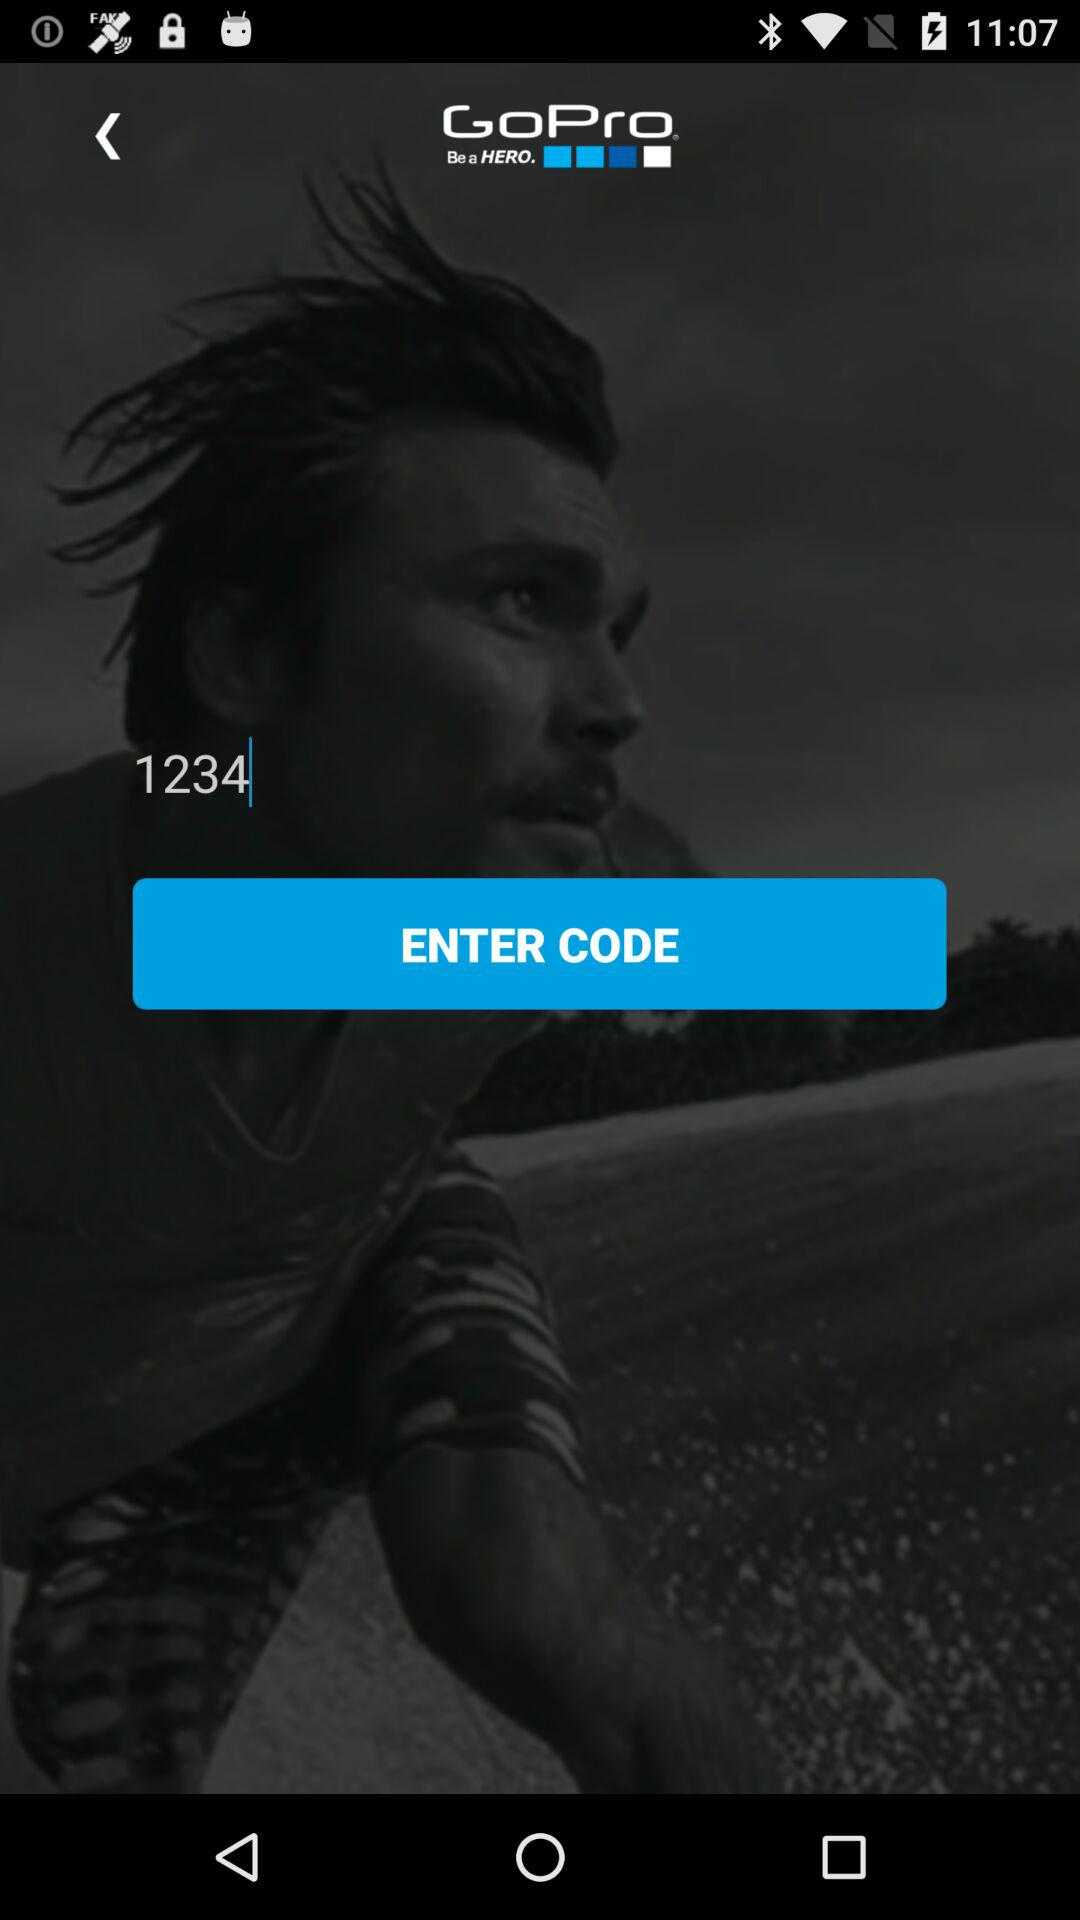What is the application name? The application name is "GoPro". 